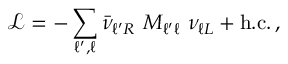Convert formula to latex. <formula><loc_0><loc_0><loc_500><loc_500>\mathcal { L } = - \sum _ { \ell ^ { \prime } , \ell } \bar { \nu } _ { \ell ^ { \prime } R } \ M _ { \ell ^ { \prime } \ell } \ \nu _ { \ell L } + h . c . \, ,</formula> 